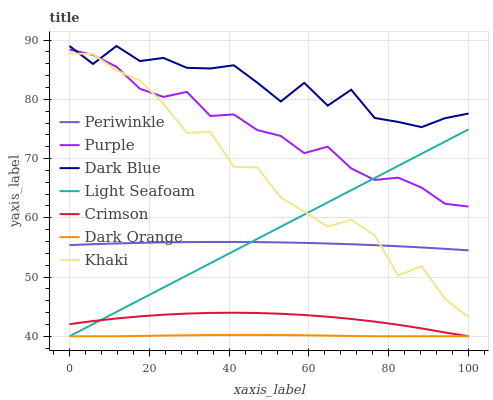Does Dark Orange have the minimum area under the curve?
Answer yes or no. Yes. Does Dark Blue have the maximum area under the curve?
Answer yes or no. Yes. Does Khaki have the minimum area under the curve?
Answer yes or no. No. Does Khaki have the maximum area under the curve?
Answer yes or no. No. Is Light Seafoam the smoothest?
Answer yes or no. Yes. Is Khaki the roughest?
Answer yes or no. Yes. Is Purple the smoothest?
Answer yes or no. No. Is Purple the roughest?
Answer yes or no. No. Does Khaki have the lowest value?
Answer yes or no. No. Does Khaki have the highest value?
Answer yes or no. No. Is Dark Orange less than Dark Blue?
Answer yes or no. Yes. Is Dark Blue greater than Periwinkle?
Answer yes or no. Yes. Does Dark Orange intersect Dark Blue?
Answer yes or no. No. 